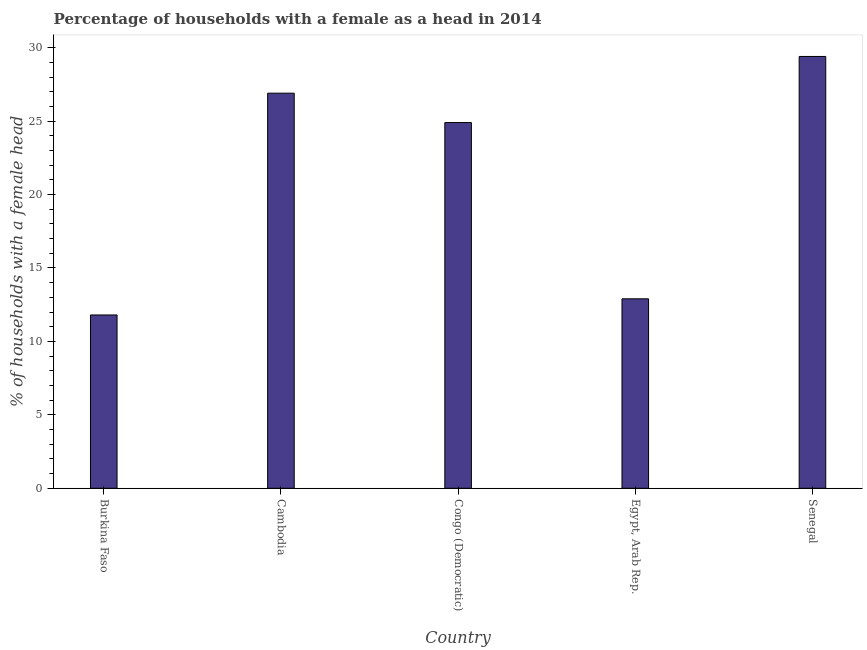Does the graph contain grids?
Provide a succinct answer. No. What is the title of the graph?
Make the answer very short. Percentage of households with a female as a head in 2014. What is the label or title of the Y-axis?
Keep it short and to the point. % of households with a female head. What is the number of female supervised households in Burkina Faso?
Your response must be concise. 11.8. Across all countries, what is the maximum number of female supervised households?
Offer a very short reply. 29.4. In which country was the number of female supervised households maximum?
Give a very brief answer. Senegal. In which country was the number of female supervised households minimum?
Your response must be concise. Burkina Faso. What is the sum of the number of female supervised households?
Keep it short and to the point. 105.9. What is the average number of female supervised households per country?
Your response must be concise. 21.18. What is the median number of female supervised households?
Offer a very short reply. 24.9. In how many countries, is the number of female supervised households greater than 10 %?
Your answer should be compact. 5. What is the ratio of the number of female supervised households in Cambodia to that in Egypt, Arab Rep.?
Keep it short and to the point. 2.08. Is the number of female supervised households in Congo (Democratic) less than that in Senegal?
Your answer should be very brief. Yes. What is the difference between the highest and the second highest number of female supervised households?
Your answer should be compact. 2.5. Is the sum of the number of female supervised households in Burkina Faso and Senegal greater than the maximum number of female supervised households across all countries?
Your response must be concise. Yes. What is the difference between the highest and the lowest number of female supervised households?
Provide a short and direct response. 17.6. Are all the bars in the graph horizontal?
Give a very brief answer. No. How many countries are there in the graph?
Give a very brief answer. 5. What is the difference between two consecutive major ticks on the Y-axis?
Provide a succinct answer. 5. Are the values on the major ticks of Y-axis written in scientific E-notation?
Ensure brevity in your answer.  No. What is the % of households with a female head of Cambodia?
Your response must be concise. 26.9. What is the % of households with a female head in Congo (Democratic)?
Offer a terse response. 24.9. What is the % of households with a female head of Senegal?
Offer a very short reply. 29.4. What is the difference between the % of households with a female head in Burkina Faso and Cambodia?
Offer a terse response. -15.1. What is the difference between the % of households with a female head in Burkina Faso and Senegal?
Keep it short and to the point. -17.6. What is the difference between the % of households with a female head in Cambodia and Congo (Democratic)?
Provide a short and direct response. 2. What is the difference between the % of households with a female head in Egypt, Arab Rep. and Senegal?
Make the answer very short. -16.5. What is the ratio of the % of households with a female head in Burkina Faso to that in Cambodia?
Offer a very short reply. 0.44. What is the ratio of the % of households with a female head in Burkina Faso to that in Congo (Democratic)?
Your answer should be very brief. 0.47. What is the ratio of the % of households with a female head in Burkina Faso to that in Egypt, Arab Rep.?
Provide a succinct answer. 0.92. What is the ratio of the % of households with a female head in Burkina Faso to that in Senegal?
Offer a terse response. 0.4. What is the ratio of the % of households with a female head in Cambodia to that in Egypt, Arab Rep.?
Provide a short and direct response. 2.08. What is the ratio of the % of households with a female head in Cambodia to that in Senegal?
Ensure brevity in your answer.  0.92. What is the ratio of the % of households with a female head in Congo (Democratic) to that in Egypt, Arab Rep.?
Provide a short and direct response. 1.93. What is the ratio of the % of households with a female head in Congo (Democratic) to that in Senegal?
Ensure brevity in your answer.  0.85. What is the ratio of the % of households with a female head in Egypt, Arab Rep. to that in Senegal?
Give a very brief answer. 0.44. 